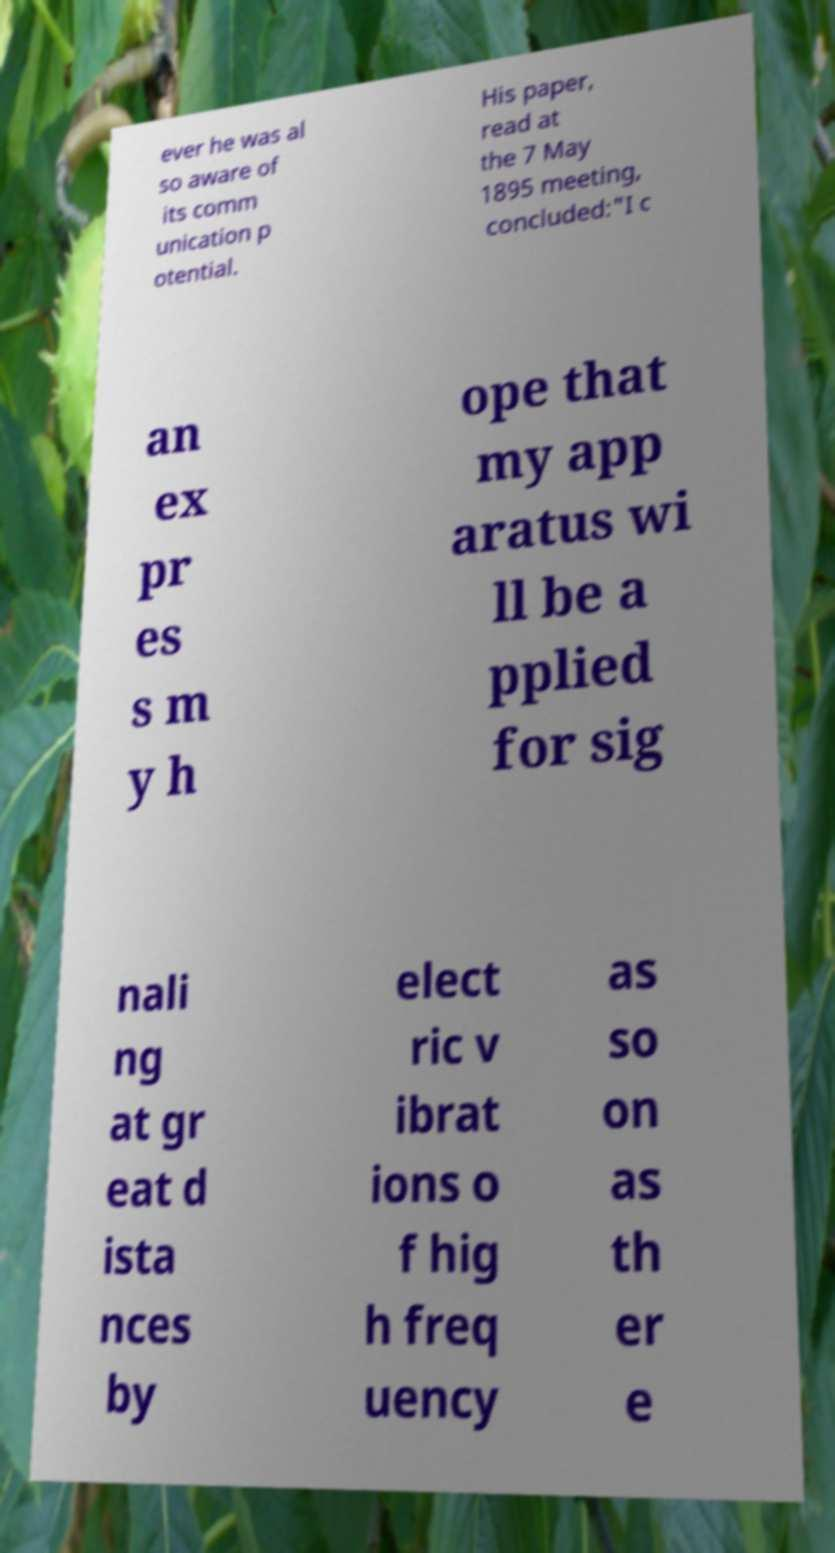Can you read and provide the text displayed in the image?This photo seems to have some interesting text. Can you extract and type it out for me? ever he was al so aware of its comm unication p otential. His paper, read at the 7 May 1895 meeting, concluded:"I c an ex pr es s m y h ope that my app aratus wi ll be a pplied for sig nali ng at gr eat d ista nces by elect ric v ibrat ions o f hig h freq uency as so on as th er e 